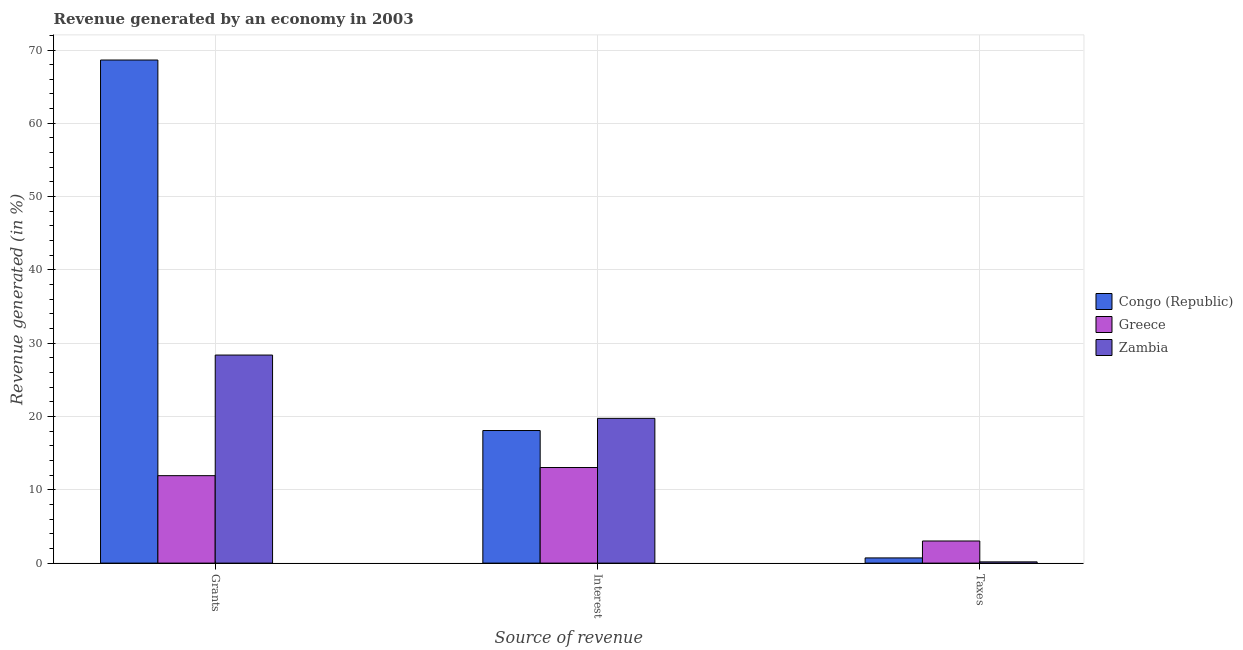Are the number of bars on each tick of the X-axis equal?
Provide a short and direct response. Yes. How many bars are there on the 3rd tick from the right?
Keep it short and to the point. 3. What is the label of the 2nd group of bars from the left?
Make the answer very short. Interest. What is the percentage of revenue generated by interest in Congo (Republic)?
Your answer should be compact. 18.09. Across all countries, what is the maximum percentage of revenue generated by interest?
Keep it short and to the point. 19.75. Across all countries, what is the minimum percentage of revenue generated by taxes?
Your response must be concise. 0.17. In which country was the percentage of revenue generated by taxes maximum?
Provide a short and direct response. Greece. In which country was the percentage of revenue generated by taxes minimum?
Your response must be concise. Zambia. What is the total percentage of revenue generated by taxes in the graph?
Your answer should be compact. 3.9. What is the difference between the percentage of revenue generated by interest in Zambia and that in Congo (Republic)?
Ensure brevity in your answer.  1.66. What is the difference between the percentage of revenue generated by taxes in Greece and the percentage of revenue generated by grants in Zambia?
Keep it short and to the point. -25.37. What is the average percentage of revenue generated by taxes per country?
Provide a succinct answer. 1.3. What is the difference between the percentage of revenue generated by grants and percentage of revenue generated by interest in Congo (Republic)?
Offer a very short reply. 50.54. What is the ratio of the percentage of revenue generated by grants in Congo (Republic) to that in Zambia?
Make the answer very short. 2.42. Is the difference between the percentage of revenue generated by interest in Zambia and Greece greater than the difference between the percentage of revenue generated by grants in Zambia and Greece?
Keep it short and to the point. No. What is the difference between the highest and the second highest percentage of revenue generated by interest?
Make the answer very short. 1.66. What is the difference between the highest and the lowest percentage of revenue generated by taxes?
Make the answer very short. 2.85. What does the 1st bar from the left in Interest represents?
Your answer should be compact. Congo (Republic). What does the 2nd bar from the right in Taxes represents?
Your answer should be very brief. Greece. Is it the case that in every country, the sum of the percentage of revenue generated by grants and percentage of revenue generated by interest is greater than the percentage of revenue generated by taxes?
Make the answer very short. Yes. How many bars are there?
Provide a succinct answer. 9. Are all the bars in the graph horizontal?
Your answer should be compact. No. What is the difference between two consecutive major ticks on the Y-axis?
Offer a terse response. 10. Does the graph contain any zero values?
Provide a short and direct response. No. Where does the legend appear in the graph?
Make the answer very short. Center right. How many legend labels are there?
Your answer should be very brief. 3. How are the legend labels stacked?
Give a very brief answer. Vertical. What is the title of the graph?
Give a very brief answer. Revenue generated by an economy in 2003. Does "Congo (Democratic)" appear as one of the legend labels in the graph?
Your response must be concise. No. What is the label or title of the X-axis?
Your answer should be compact. Source of revenue. What is the label or title of the Y-axis?
Make the answer very short. Revenue generated (in %). What is the Revenue generated (in %) in Congo (Republic) in Grants?
Keep it short and to the point. 68.63. What is the Revenue generated (in %) in Greece in Grants?
Your response must be concise. 11.93. What is the Revenue generated (in %) of Zambia in Grants?
Your response must be concise. 28.38. What is the Revenue generated (in %) of Congo (Republic) in Interest?
Your answer should be very brief. 18.09. What is the Revenue generated (in %) in Greece in Interest?
Offer a very short reply. 13.04. What is the Revenue generated (in %) of Zambia in Interest?
Your response must be concise. 19.75. What is the Revenue generated (in %) in Congo (Republic) in Taxes?
Provide a succinct answer. 0.71. What is the Revenue generated (in %) of Greece in Taxes?
Your answer should be very brief. 3.02. What is the Revenue generated (in %) in Zambia in Taxes?
Keep it short and to the point. 0.17. Across all Source of revenue, what is the maximum Revenue generated (in %) in Congo (Republic)?
Keep it short and to the point. 68.63. Across all Source of revenue, what is the maximum Revenue generated (in %) of Greece?
Make the answer very short. 13.04. Across all Source of revenue, what is the maximum Revenue generated (in %) of Zambia?
Offer a terse response. 28.38. Across all Source of revenue, what is the minimum Revenue generated (in %) of Congo (Republic)?
Make the answer very short. 0.71. Across all Source of revenue, what is the minimum Revenue generated (in %) in Greece?
Your response must be concise. 3.02. Across all Source of revenue, what is the minimum Revenue generated (in %) of Zambia?
Your answer should be compact. 0.17. What is the total Revenue generated (in %) of Congo (Republic) in the graph?
Your answer should be compact. 87.43. What is the total Revenue generated (in %) of Greece in the graph?
Make the answer very short. 27.99. What is the total Revenue generated (in %) of Zambia in the graph?
Provide a short and direct response. 48.3. What is the difference between the Revenue generated (in %) in Congo (Republic) in Grants and that in Interest?
Your answer should be very brief. 50.54. What is the difference between the Revenue generated (in %) in Greece in Grants and that in Interest?
Offer a terse response. -1.11. What is the difference between the Revenue generated (in %) of Zambia in Grants and that in Interest?
Your response must be concise. 8.63. What is the difference between the Revenue generated (in %) of Congo (Republic) in Grants and that in Taxes?
Provide a succinct answer. 67.92. What is the difference between the Revenue generated (in %) of Greece in Grants and that in Taxes?
Give a very brief answer. 8.91. What is the difference between the Revenue generated (in %) of Zambia in Grants and that in Taxes?
Give a very brief answer. 28.21. What is the difference between the Revenue generated (in %) in Congo (Republic) in Interest and that in Taxes?
Provide a succinct answer. 17.38. What is the difference between the Revenue generated (in %) of Greece in Interest and that in Taxes?
Your response must be concise. 10.02. What is the difference between the Revenue generated (in %) of Zambia in Interest and that in Taxes?
Provide a short and direct response. 19.58. What is the difference between the Revenue generated (in %) in Congo (Republic) in Grants and the Revenue generated (in %) in Greece in Interest?
Your answer should be very brief. 55.59. What is the difference between the Revenue generated (in %) in Congo (Republic) in Grants and the Revenue generated (in %) in Zambia in Interest?
Provide a short and direct response. 48.88. What is the difference between the Revenue generated (in %) of Greece in Grants and the Revenue generated (in %) of Zambia in Interest?
Give a very brief answer. -7.82. What is the difference between the Revenue generated (in %) of Congo (Republic) in Grants and the Revenue generated (in %) of Greece in Taxes?
Make the answer very short. 65.61. What is the difference between the Revenue generated (in %) in Congo (Republic) in Grants and the Revenue generated (in %) in Zambia in Taxes?
Offer a very short reply. 68.46. What is the difference between the Revenue generated (in %) of Greece in Grants and the Revenue generated (in %) of Zambia in Taxes?
Offer a very short reply. 11.76. What is the difference between the Revenue generated (in %) of Congo (Republic) in Interest and the Revenue generated (in %) of Greece in Taxes?
Your response must be concise. 15.07. What is the difference between the Revenue generated (in %) in Congo (Republic) in Interest and the Revenue generated (in %) in Zambia in Taxes?
Provide a succinct answer. 17.92. What is the difference between the Revenue generated (in %) of Greece in Interest and the Revenue generated (in %) of Zambia in Taxes?
Provide a succinct answer. 12.87. What is the average Revenue generated (in %) in Congo (Republic) per Source of revenue?
Offer a very short reply. 29.14. What is the average Revenue generated (in %) in Greece per Source of revenue?
Ensure brevity in your answer.  9.33. What is the average Revenue generated (in %) in Zambia per Source of revenue?
Make the answer very short. 16.1. What is the difference between the Revenue generated (in %) in Congo (Republic) and Revenue generated (in %) in Greece in Grants?
Provide a succinct answer. 56.7. What is the difference between the Revenue generated (in %) in Congo (Republic) and Revenue generated (in %) in Zambia in Grants?
Offer a terse response. 40.25. What is the difference between the Revenue generated (in %) in Greece and Revenue generated (in %) in Zambia in Grants?
Keep it short and to the point. -16.45. What is the difference between the Revenue generated (in %) in Congo (Republic) and Revenue generated (in %) in Greece in Interest?
Offer a terse response. 5.05. What is the difference between the Revenue generated (in %) in Congo (Republic) and Revenue generated (in %) in Zambia in Interest?
Provide a succinct answer. -1.66. What is the difference between the Revenue generated (in %) of Greece and Revenue generated (in %) of Zambia in Interest?
Your answer should be very brief. -6.71. What is the difference between the Revenue generated (in %) in Congo (Republic) and Revenue generated (in %) in Greece in Taxes?
Provide a short and direct response. -2.31. What is the difference between the Revenue generated (in %) in Congo (Republic) and Revenue generated (in %) in Zambia in Taxes?
Make the answer very short. 0.54. What is the difference between the Revenue generated (in %) in Greece and Revenue generated (in %) in Zambia in Taxes?
Your response must be concise. 2.85. What is the ratio of the Revenue generated (in %) in Congo (Republic) in Grants to that in Interest?
Offer a very short reply. 3.79. What is the ratio of the Revenue generated (in %) in Greece in Grants to that in Interest?
Make the answer very short. 0.91. What is the ratio of the Revenue generated (in %) in Zambia in Grants to that in Interest?
Give a very brief answer. 1.44. What is the ratio of the Revenue generated (in %) of Congo (Republic) in Grants to that in Taxes?
Your answer should be very brief. 96.86. What is the ratio of the Revenue generated (in %) in Greece in Grants to that in Taxes?
Keep it short and to the point. 3.95. What is the ratio of the Revenue generated (in %) in Zambia in Grants to that in Taxes?
Your response must be concise. 167.03. What is the ratio of the Revenue generated (in %) in Congo (Republic) in Interest to that in Taxes?
Your answer should be compact. 25.53. What is the ratio of the Revenue generated (in %) in Greece in Interest to that in Taxes?
Your response must be concise. 4.32. What is the ratio of the Revenue generated (in %) in Zambia in Interest to that in Taxes?
Provide a short and direct response. 116.22. What is the difference between the highest and the second highest Revenue generated (in %) in Congo (Republic)?
Offer a very short reply. 50.54. What is the difference between the highest and the second highest Revenue generated (in %) in Greece?
Your response must be concise. 1.11. What is the difference between the highest and the second highest Revenue generated (in %) in Zambia?
Your response must be concise. 8.63. What is the difference between the highest and the lowest Revenue generated (in %) in Congo (Republic)?
Your answer should be compact. 67.92. What is the difference between the highest and the lowest Revenue generated (in %) of Greece?
Ensure brevity in your answer.  10.02. What is the difference between the highest and the lowest Revenue generated (in %) of Zambia?
Offer a terse response. 28.21. 